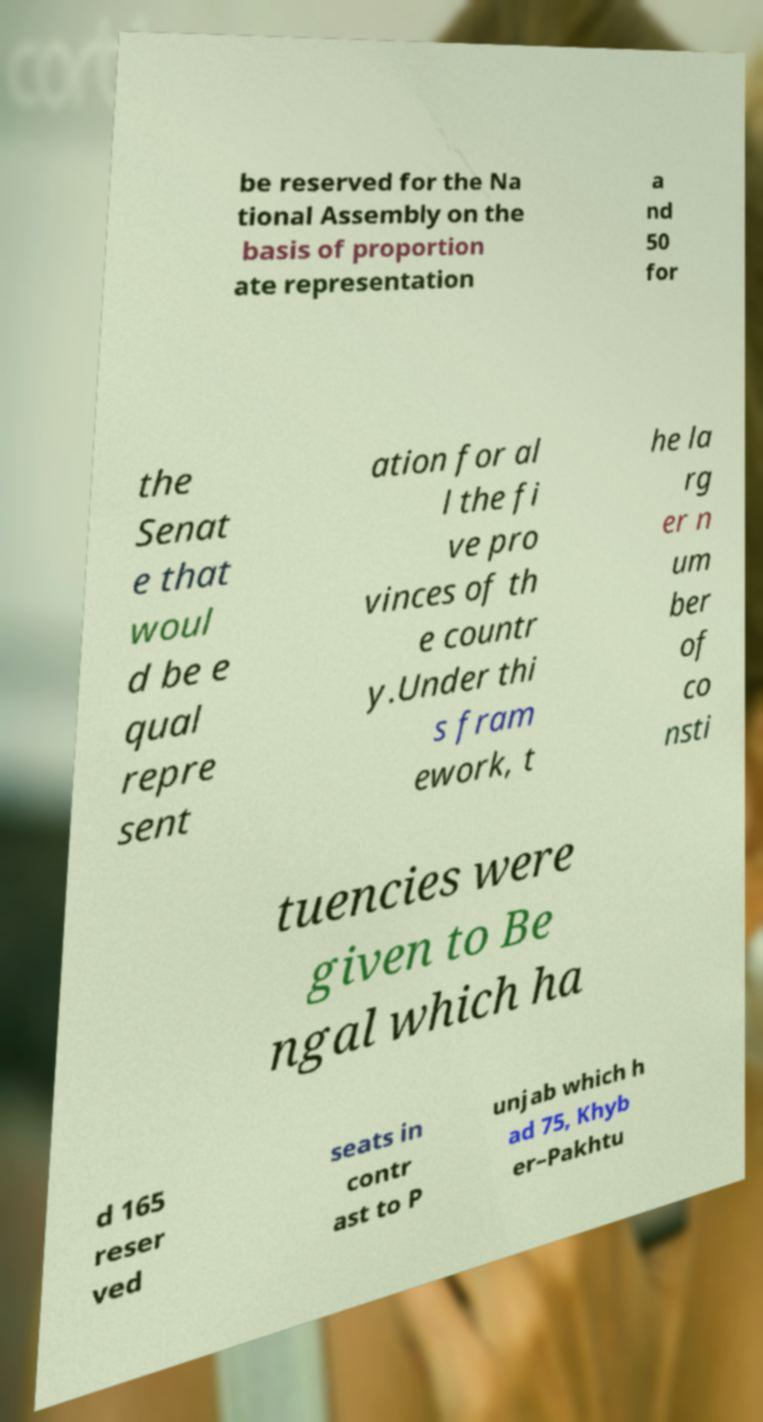Can you read and provide the text displayed in the image?This photo seems to have some interesting text. Can you extract and type it out for me? be reserved for the Na tional Assembly on the basis of proportion ate representation a nd 50 for the Senat e that woul d be e qual repre sent ation for al l the fi ve pro vinces of th e countr y.Under thi s fram ework, t he la rg er n um ber of co nsti tuencies were given to Be ngal which ha d 165 reser ved seats in contr ast to P unjab which h ad 75, Khyb er–Pakhtu 